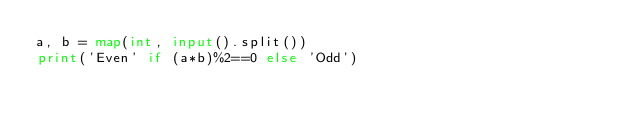<code> <loc_0><loc_0><loc_500><loc_500><_Python_>a, b = map(int, input().split())
print('Even' if (a*b)%2==0 else 'Odd')</code> 